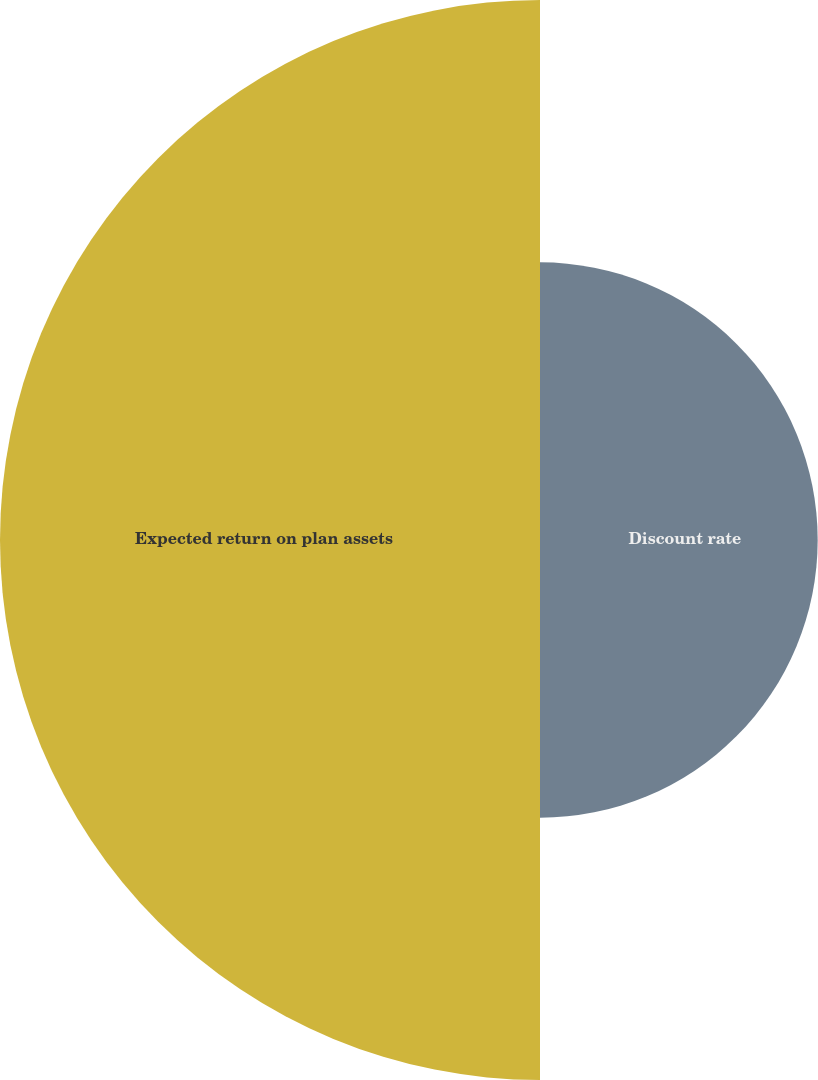Convert chart to OTSL. <chart><loc_0><loc_0><loc_500><loc_500><pie_chart><fcel>Discount rate<fcel>Expected return on plan assets<nl><fcel>33.96%<fcel>66.04%<nl></chart> 